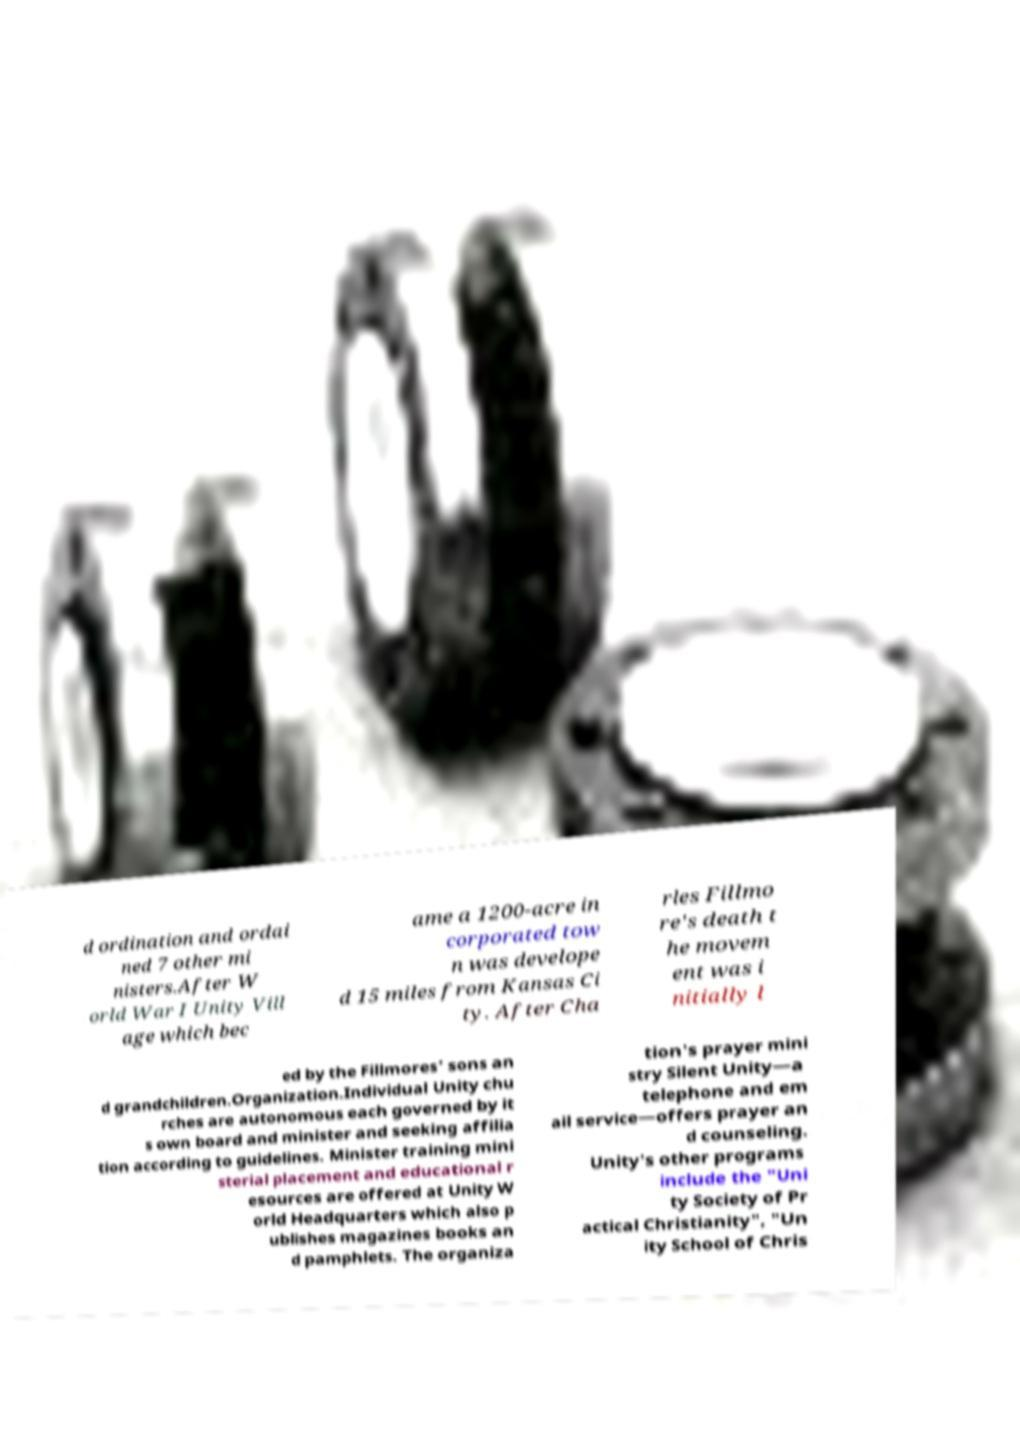I need the written content from this picture converted into text. Can you do that? d ordination and ordai ned 7 other mi nisters.After W orld War I Unity Vill age which bec ame a 1200-acre in corporated tow n was develope d 15 miles from Kansas Ci ty. After Cha rles Fillmo re's death t he movem ent was i nitially l ed by the Fillmores’ sons an d grandchildren.Organization.Individual Unity chu rches are autonomous each governed by it s own board and minister and seeking affilia tion according to guidelines. Minister training mini sterial placement and educational r esources are offered at Unity W orld Headquarters which also p ublishes magazines books an d pamphlets. The organiza tion's prayer mini stry Silent Unity—a telephone and em ail service—offers prayer an d counseling. Unity's other programs include the "Uni ty Society of Pr actical Christianity", "Un ity School of Chris 